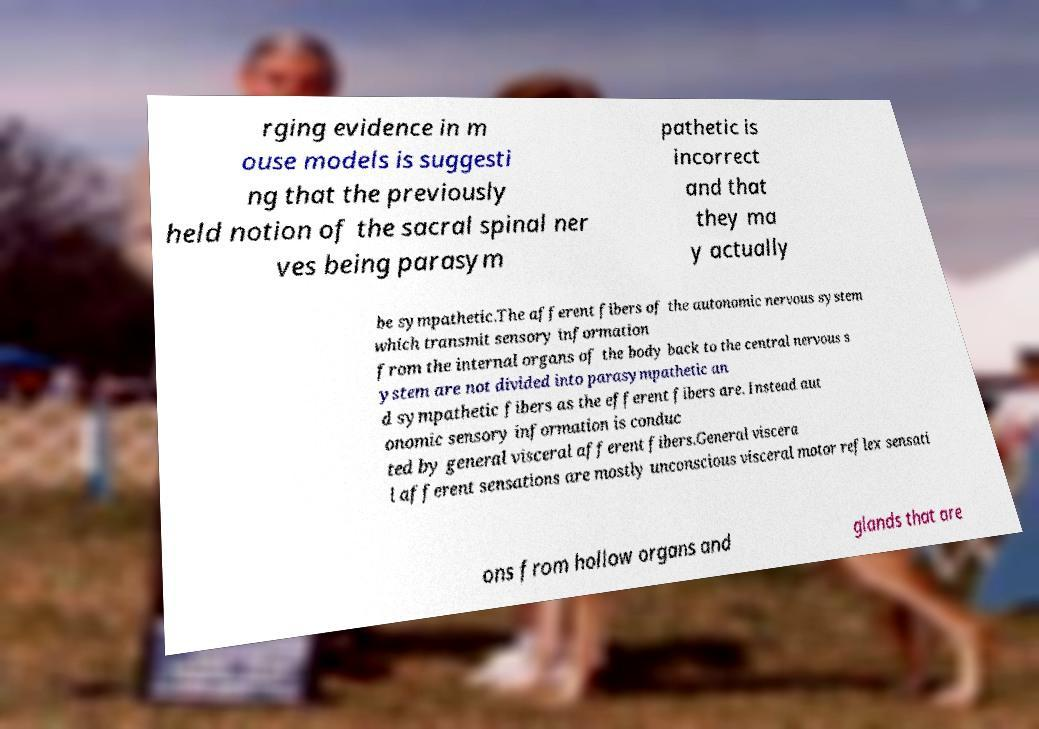Please identify and transcribe the text found in this image. rging evidence in m ouse models is suggesti ng that the previously held notion of the sacral spinal ner ves being parasym pathetic is incorrect and that they ma y actually be sympathetic.The afferent fibers of the autonomic nervous system which transmit sensory information from the internal organs of the body back to the central nervous s ystem are not divided into parasympathetic an d sympathetic fibers as the efferent fibers are. Instead aut onomic sensory information is conduc ted by general visceral afferent fibers.General viscera l afferent sensations are mostly unconscious visceral motor reflex sensati ons from hollow organs and glands that are 